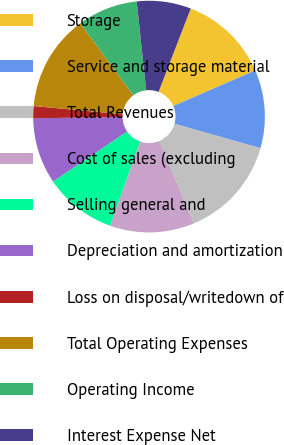Convert chart to OTSL. <chart><loc_0><loc_0><loc_500><loc_500><pie_chart><fcel>Storage<fcel>Service and storage material<fcel>Total Revenues<fcel>Cost of sales (excluding<fcel>Selling general and<fcel>Depreciation and amortization<fcel>Loss on disposal/writedown of<fcel>Total Operating Expenses<fcel>Operating Income<fcel>Interest Expense Net<nl><fcel>12.61%<fcel>10.92%<fcel>14.29%<fcel>11.76%<fcel>10.08%<fcel>9.24%<fcel>1.68%<fcel>13.45%<fcel>8.4%<fcel>7.56%<nl></chart> 